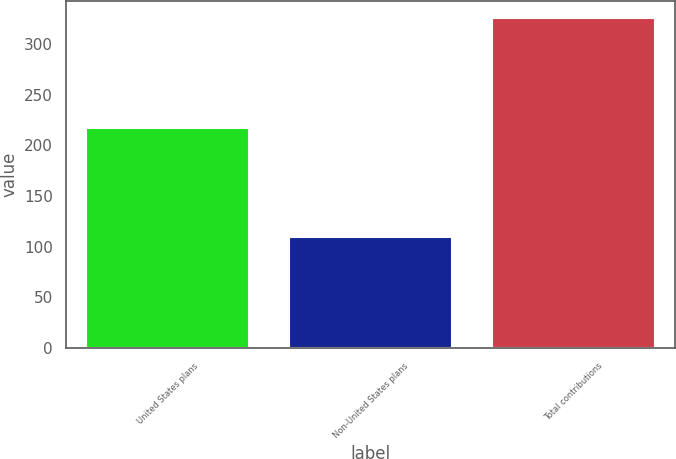<chart> <loc_0><loc_0><loc_500><loc_500><bar_chart><fcel>United States plans<fcel>Non-United States plans<fcel>Total contributions<nl><fcel>217<fcel>109<fcel>326<nl></chart> 